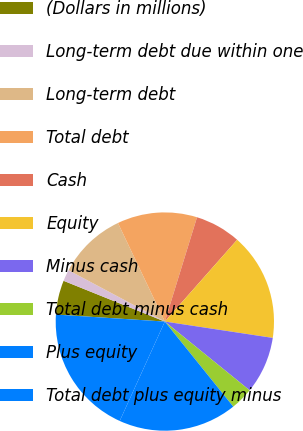<chart> <loc_0><loc_0><loc_500><loc_500><pie_chart><fcel>(Dollars in millions)<fcel>Long-term debt due within one<fcel>Long-term debt<fcel>Total debt<fcel>Cash<fcel>Equity<fcel>Minus cash<fcel>Total debt minus cash<fcel>Plus equity<fcel>Total debt plus equity minus<nl><fcel>5.07%<fcel>1.7%<fcel>10.14%<fcel>11.83%<fcel>6.76%<fcel>15.87%<fcel>8.45%<fcel>3.38%<fcel>17.56%<fcel>19.24%<nl></chart> 